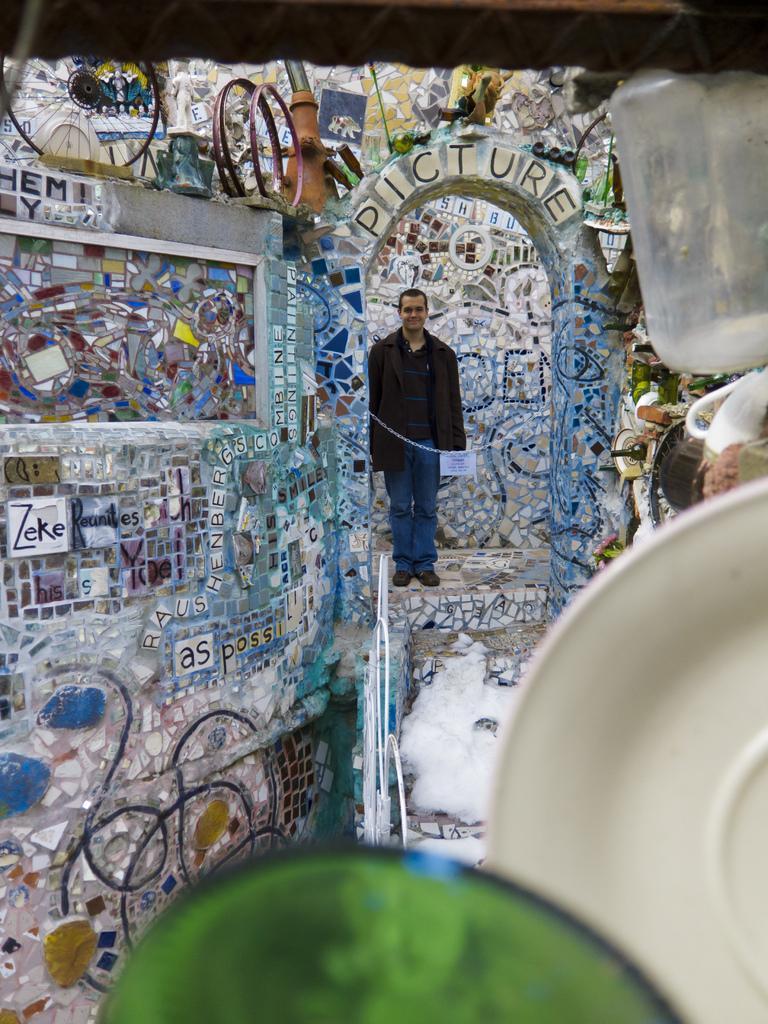Please provide a concise description of this image. In this picture we can see a person standing on the ground, here we can see some objects. 